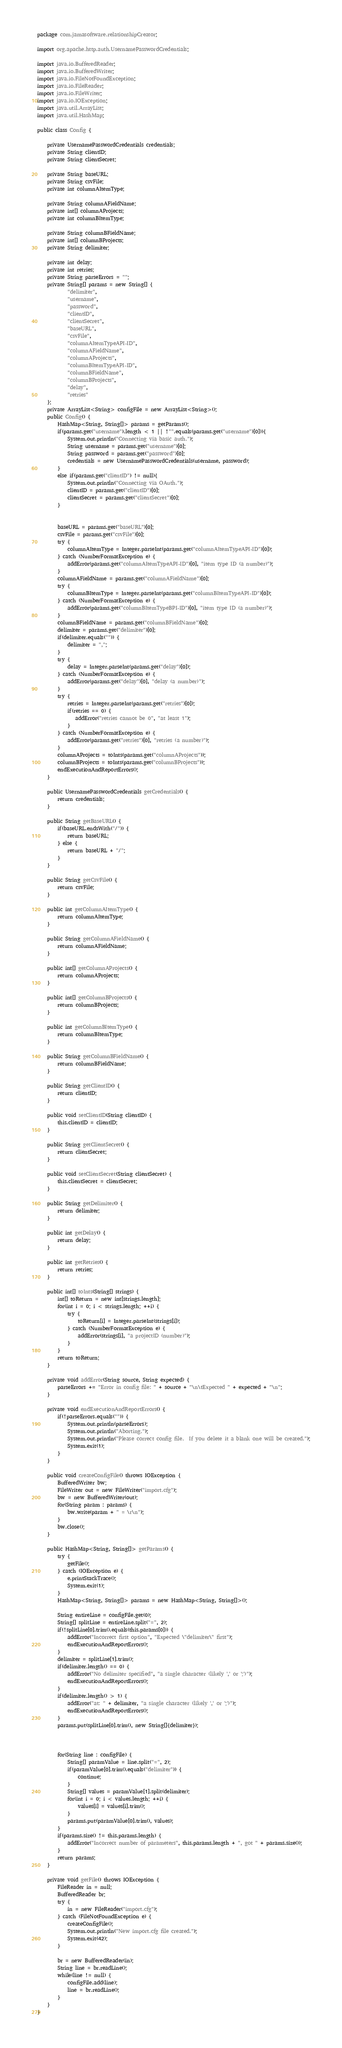<code> <loc_0><loc_0><loc_500><loc_500><_Java_>package com.jamasoftware.relationshipCreator;

import org.apache.http.auth.UsernamePasswordCredentials;

import java.io.BufferedReader;
import java.io.BufferedWriter;
import java.io.FileNotFoundException;
import java.io.FileReader;
import java.io.FileWriter;
import java.io.IOException;
import java.util.ArrayList;
import java.util.HashMap;

public class Config {

    private UsernamePasswordCredentials credentials;
    private String clientID;
    private String clientSecret;

    private String baseURL;
    private String csvFile;
    private int columnAItemType;

    private String columnAFieldName;
    private int[] columnAProjects;
    private int columnBItemType;

    private String columnBFieldName;
    private int[] columnBProjects;
    private String delimiter;

    private int delay;
    private int retries;
    private String parseErrors = "";
    private String[] params = new String[] {
            "delimiter",
            "username",
            "password",
            "clientID",
            "clientSecret",
            "baseURL",
            "csvFile",
            "columnAItemTypeAPI-ID",
            "columnAFieldName",
            "columnAProjects",
            "columnBItemTypeAPI-ID",
            "columnBFieldName",
            "columnBProjects",
            "delay",
            "retries"
    };
    private ArrayList<String> configFile = new ArrayList<String>();
    public Config() {
        HashMap<String, String[]> params = getParams();
        if(params.get("username").length < 1 || !"".equals(params.get("username")[0])){
            System.out.println("Connecting via basic auth.");
            String username = params.get("username")[0];
            String password = params.get("password")[0];
            credentials = new UsernamePasswordCredentials(username, password);
        }
        else if(params.get("clientID") != null){
            System.out.println("Connecting via OAuth.");
            clientID = params.get("clientID")[0];
            clientSecret = params.get("clientSecret")[0];
        }


        baseURL = params.get("baseURL")[0];
        csvFile = params.get("csvFile")[0];
        try {
            columnAItemType = Integer.parseInt(params.get("columnAItemTypeAPI-ID")[0]);
        } catch (NumberFormatException e) {
            addError(params.get("columnAItemTypeAPI-ID")[0], "item type ID (a number)");
        }
        columnAFieldName = params.get("columnAFieldName")[0];
        try {
            columnBItemType = Integer.parseInt(params.get("columnBItemTypeAPI-ID")[0]);
        } catch (NumberFormatException e) {
            addError(params.get("columnBItemTypeBPI-ID")[0], "item type ID (a number)");
        }
        columnBFieldName = params.get("columnBFieldName")[0];
        delimiter = params.get("delimiter")[0];
        if(delimiter.equals("")) {
            delimiter = ",";
        }
        try {
            delay = Integer.parseInt(params.get("delay")[0]);
        } catch (NumberFormatException e) {
            addError(params.get("delay")[0], "delay (a number)");
        }
        try {
            retries = Integer.parseInt(params.get("retries")[0]);
            if(retries == 0) {
               addError("retries cannot be 0", "at least 1");
            }
        } catch (NumberFormatException e) {
            addError(params.get("retries")[0], "retries (a number)");
        }
        columnAProjects = toInts(params.get("columnAProjects"));
        columnBProjects = toInts(params.get("columnBProjects"));
        endExecutionAndReportErrors();
    }

    public UsernamePasswordCredentials getCredentials() {
        return credentials;
    }

    public String getBaseURL() {
        if(baseURL.endsWith("/")) {
            return baseURL;
        } else {
            return baseURL + "/";
        }
    }

    public String getCsvFile() {
        return csvFile;
    }

    public int getColumnAItemType() {
        return columnAItemType;
    }

    public String getColumnAFieldName() {
        return columnAFieldName;
    }

    public int[] getColumnAProjects() {
        return columnAProjects;
    }

    public int[] getColumnBProjects() {
        return columnBProjects;
    }

    public int getColumnBItemType() {
        return columnBItemType;
    }

    public String getColumnBFieldName() {
        return columnBFieldName;
    }

    public String getClientID() {
        return clientID;
    }

    public void setClientID(String clientID) {
        this.clientID = clientID;
    }

    public String getClientSecret() {
        return clientSecret;
    }

    public void setClientSecret(String clientSecret) {
        this.clientSecret = clientSecret;
    }

    public String getDelimiter() {
        return delimiter;
    }

    public int getDelay() {
        return delay;
    }

    public int getRetries() {
        return retries;
    }

    public int[] toInts(String[] strings) {
        int[] toReturn = new int[strings.length];
        for(int i = 0; i < strings.length; ++i) {
            try {
                toReturn[i] = Integer.parseInt(strings[i]);
            } catch (NumberFormatException e) {
                addError(strings[i], "a projectID (number)");
            }
        }
        return toReturn;
    }

    private void addError(String source, String expected) {
        parseErrors += "Error in config file: " + source + "\n\tExpected " + expected + "\n";
    }

    private void endExecutionAndReportErrors() {
        if(!parseErrors.equals("")) {
            System.out.println(parseErrors);
            System.out.println("Aborting.");
            System.out.println("Please correct config file.  If you delete it a blank one will be created.");
            System.exit(1);
        }
    }

    public void createConfigFile() throws IOException {
        BufferedWriter bw;
        FileWriter out = new FileWriter("import.cfg");
        bw = new BufferedWriter(out);
        for(String param : params) {
            bw.write(param + " = \r\n");
        }
        bw.close();
    }

    public HashMap<String, String[]> getParams() {
        try {
            getFile();
        } catch (IOException e) {
            e.printStackTrace();
            System.exit(1);
        }
        HashMap<String, String[]> params = new HashMap<String, String[]>();

        String entireLine = configFile.get(0);
        String[] splitLine = entireLine.split("=", 2);
        if(!splitLine[0].trim().equals(this.params[0])) {
            addError("Incorrect first option", "Expected \"delimiter\" first");
            endExecutionAndReportErrors();
        }
        delimiter = splitLine[1].trim();
        if(delimiter.length() == 0) {
            addError("No delimiter specified", "a single character (likely ',' or ';')");
            endExecutionAndReportErrors();
        }
        if(delimiter.length() > 1) {
            addError("at: " + delimiter, "a single character (likely ',' or ';')");
            endExecutionAndReportErrors();
        }
        params.put(splitLine[0].trim(), new String[]{delimiter});



        for(String line : configFile) {
            String[] paramValue = line.split("=", 2);
            if(paramValue[0].trim().equals("delimiter")) {
                continue;
            }
            String[] values = paramValue[1].split(delimiter);
            for(int i = 0; i < values.length; ++i) {
                values[i] = values[i].trim();
            }
            params.put(paramValue[0].trim(), values);
        }
        if(params.size() != this.params.length) {
            addError("Incorrect number of parameters", this.params.length + ", got " + params.size());
        }
        return params;
    }

    private void getFile() throws IOException {
        FileReader in = null;
        BufferedReader br;
        try {
            in = new FileReader("import.cfg");
        } catch (FileNotFoundException e) {
            createConfigFile();
            System.out.println("New import.cfg file created.");
            System.exit(42);
        }

        br = new BufferedReader(in);
        String line = br.readLine();
        while(line != null) {
            configFile.add(line);
            line = br.readLine();
        }
    }
}
</code> 